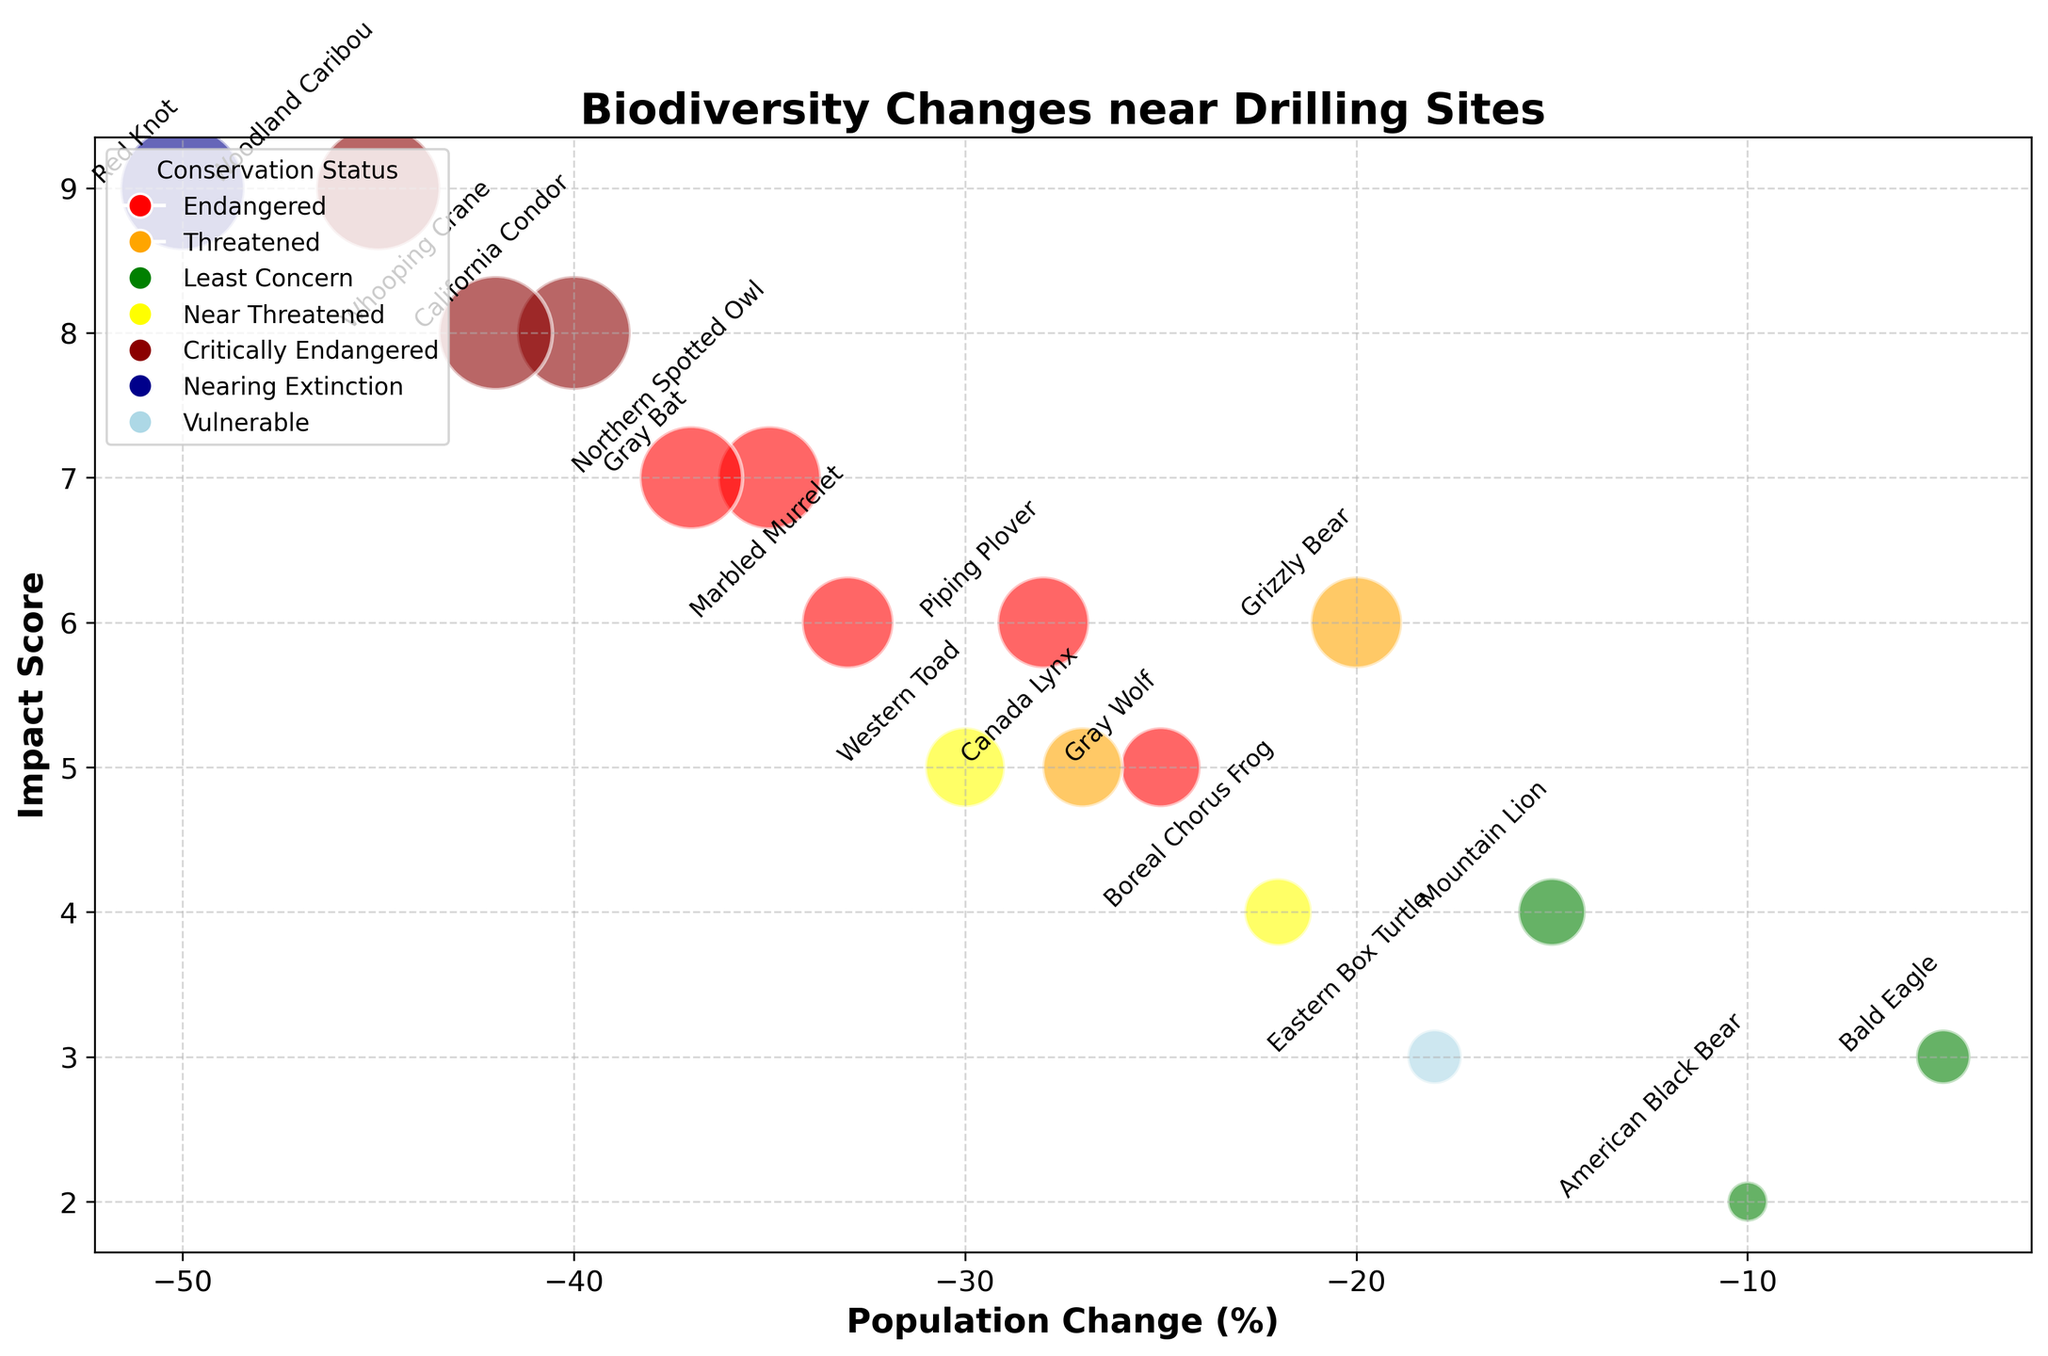What is the population change of the species with the highest Impact Score? To identify the species, look for the point with the highest position along the Impact Score axis. The Woodland Caribou has the highest Impact Score of 9, and its Population Change is -45%.
Answer: -45% Which species is closest to a 0% population change but still shows a negative change? Look for species closest to the y-axis but still on the left side. The Bald Eagle is the nearest to 0% with a Population Change of -5%.
Answer: Bald Eagle Which conservation status category has the most negative population change, and what is that change? Find the lowest population change for each category and compare them. The Red Knot in the Nearing Extinction category has the most negative population change of -50%.
Answer: Nearing Extinction, -50% Which species have an Impact Score greater than 7? Count species with Impact Scores greater than 7 by looking for points above the 7 mark on the y-axis. The species are Red Knot, California Condor, Whooping Crane, Gray Bat, and Northern Spotted Owl.
Answer: Red Knot, California Condor, Whooping Crane, Gray Bat, Northern Spotted Owl What is the average Impact Score of the Critically Endangered species? List the Impact Scores of the Critically Endangered species: California Condor (8), Woodland Caribou (9), and Whooping Crane (8). Sum them (8+9+8=25) and divide by the number of species (25/3=8.33).
Answer: 8.33 Which species shows the most negative population change among the Endangered species? Look for the most negative population change within the Endangered status category. The Gray Bat shows a population change of -37%, which is the lowest among the Endangered species.
Answer: Gray Bat How many Near Threatened species are there, and what is their average Impact Score? Identify the Near Threatened species: Western Toad and Boreal Chorus Frog. Their Impact Scores are 5 and 4 respectively. Sum them (5+4=9) and divide by 2 (9/2=4.5).
Answer: 2 species, 4.5 Which species has a higher Impact Score, the Piping Plover or the Canada Lynx? Compare the Impact Scores of the two species. The Piping Plover has an Impact Score of 6, while the Canada Lynx has a score of 5.
Answer: Piping Plover What is the total population change for Critically Endangered and Endangered species combined? Add the Population Changes of all Critically Endangered (-40, -45, -42) and Endangered (-35, -25, -33, -28, -37) species. Sum: (-40-45-42-35-25-33-28-37=-285).
Answer: -285 Which species with a Vulnerable conservation status has the smallest Impact Score? Look at the point with Vulnerable status and check its Impact Score. Eastern Box Turtle, with an Impact Score of 3, is the only species in this category.
Answer: Eastern Box Turtle 